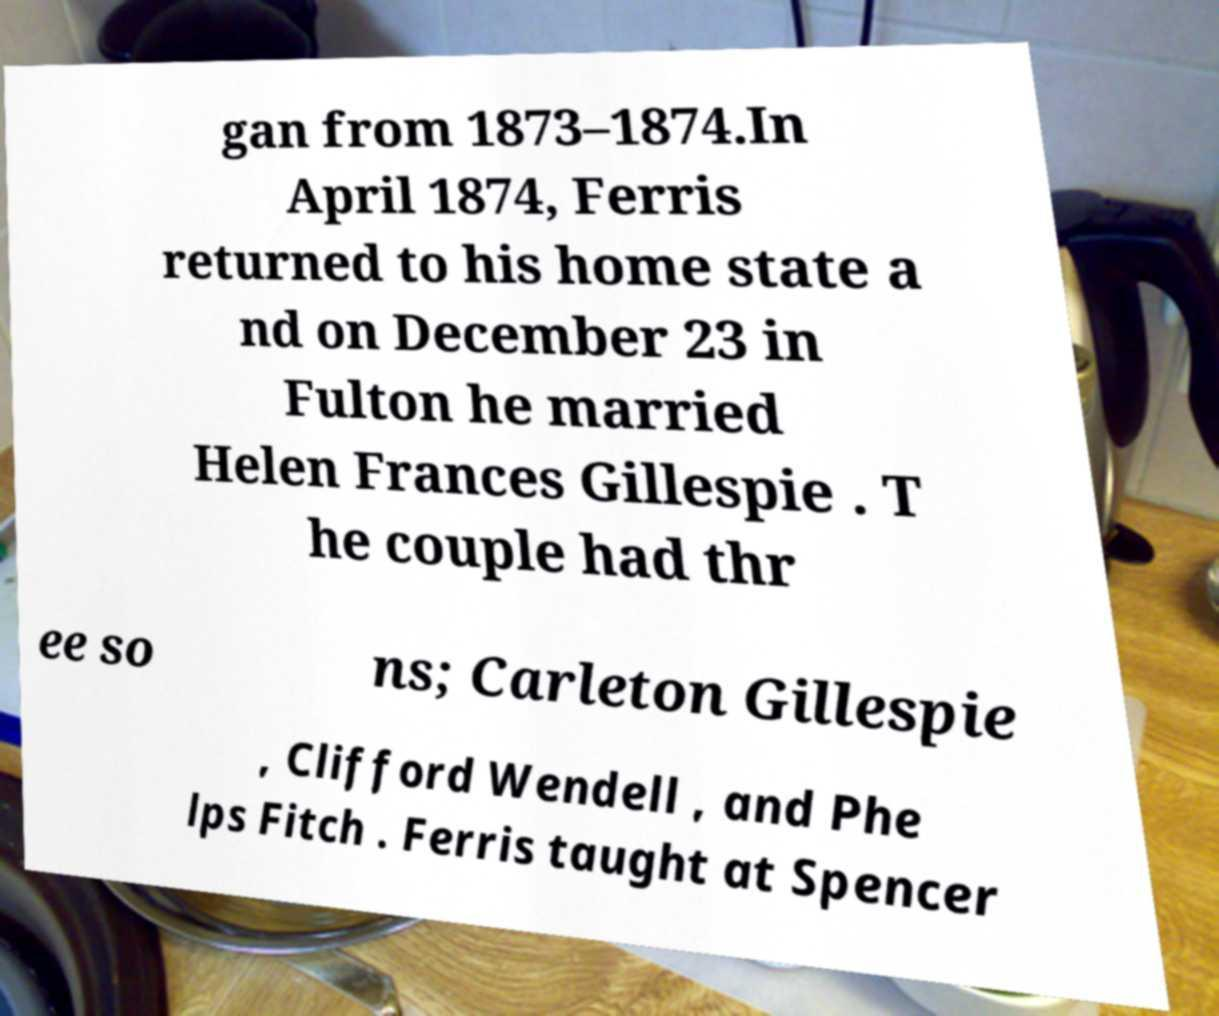Please identify and transcribe the text found in this image. gan from 1873–1874.In April 1874, Ferris returned to his home state a nd on December 23 in Fulton he married Helen Frances Gillespie . T he couple had thr ee so ns; Carleton Gillespie , Clifford Wendell , and Phe lps Fitch . Ferris taught at Spencer 